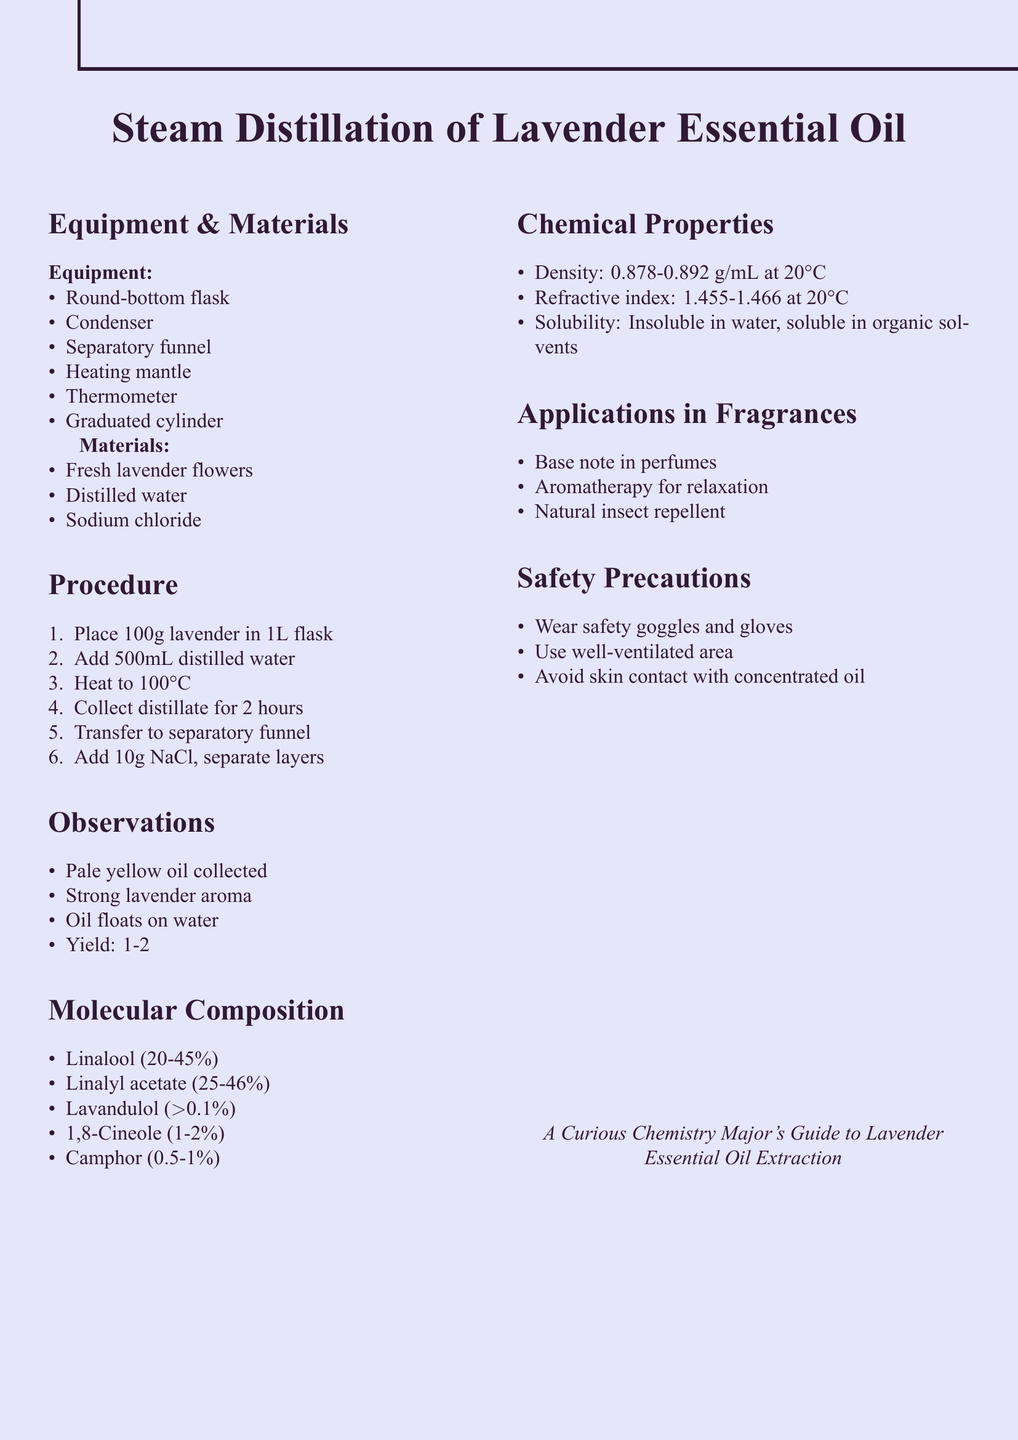What is the title of the experiment? The title of the experiment is mentioned at the top of the document.
Answer: Steam Distillation of Lavender Essential Oil How much lavender is used in the procedure? The amount of lavender used is noted in the procedure section.
Answer: 100g What equipment is used in this experiment? The equipment required for the experiment is listed in the document.
Answer: Round-bottom flask, condenser, separatory funnel, heating mantle, thermometer, graduated cylinder What is the yield of oil extracted from the lavender? The yield is specified in the observations section of the document.
Answer: Approximately 1-2% of the fresh flower weight What are the main components of lavender essential oil? The molecular composition includes specific components listed in the document.
Answer: Linalool, Linalyl acetate, Lavandulol, 1,8-Cineole, Camphor Which chemical property of the oil indicates its density? The chemical properties section provides specific data points, including density.
Answer: 0.878-0.892 g/mL at 20°C What is one application of lavender essential oil in fragrances? Applications in fragrances are mentioned in a list in the document.
Answer: Base note in perfumes What safety precaution should be taken during the experiment? Safety precautions are listed out to ensure proper conduct during the experiment.
Answer: Wear safety goggles and gloves Which chemical is used for salting out in the extraction process? The materials section lists all required materials, including the salting agent.
Answer: Sodium chloride What is the refractive index range for the lavender oil? This specific property is detailed in the chemical properties section of the document.
Answer: 1.455-1.466 at 20°C 